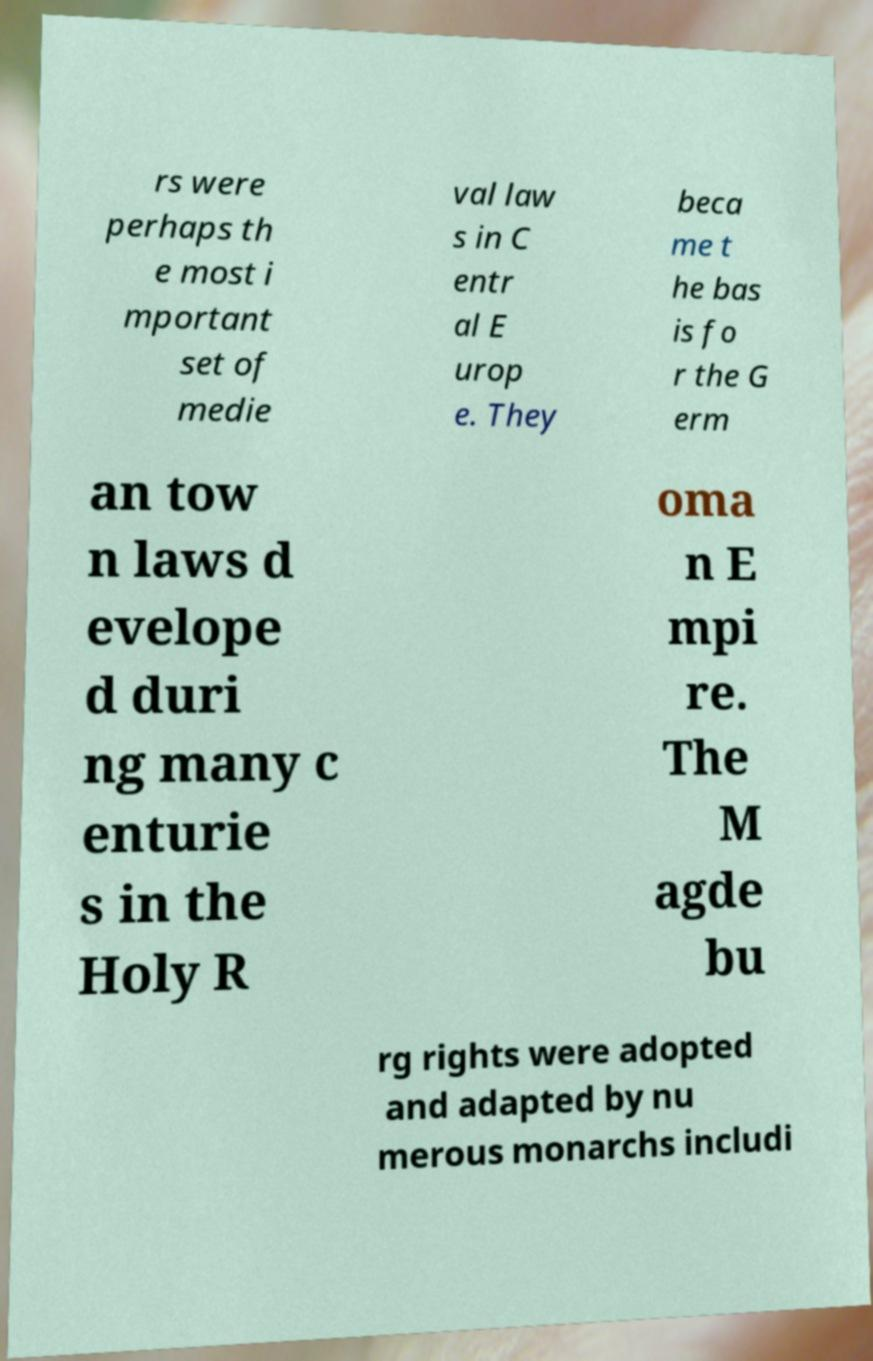Please read and relay the text visible in this image. What does it say? rs were perhaps th e most i mportant set of medie val law s in C entr al E urop e. They beca me t he bas is fo r the G erm an tow n laws d evelope d duri ng many c enturie s in the Holy R oma n E mpi re. The M agde bu rg rights were adopted and adapted by nu merous monarchs includi 